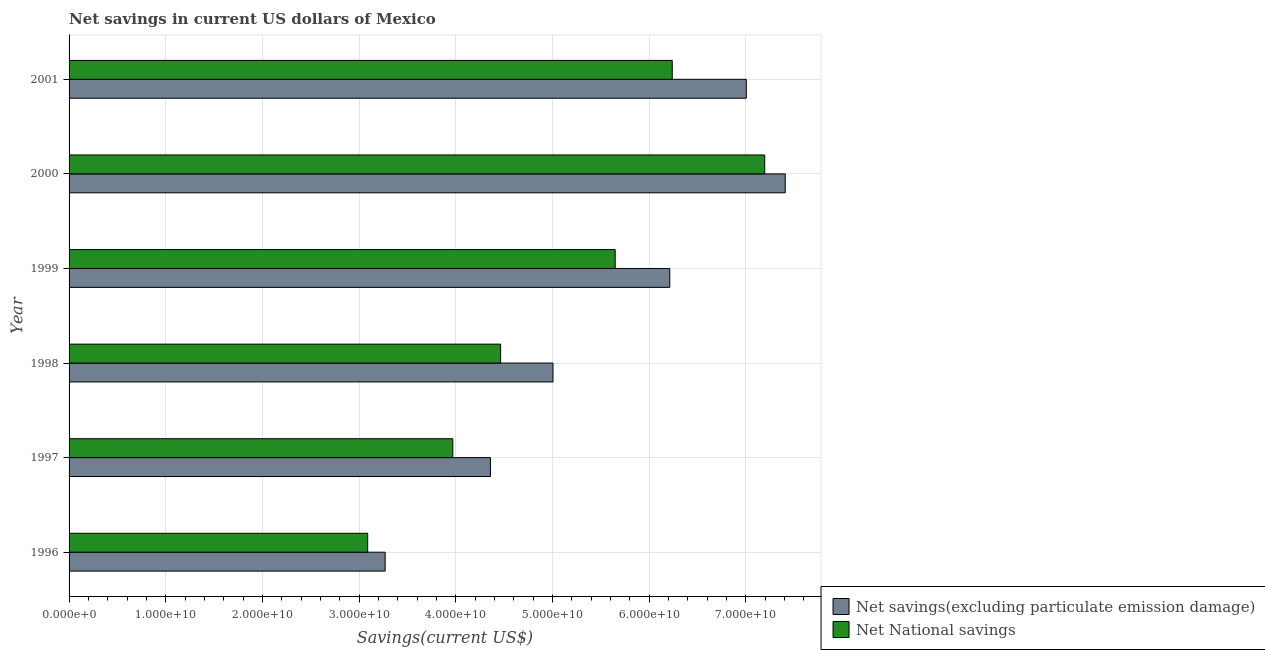How many different coloured bars are there?
Offer a terse response. 2. How many groups of bars are there?
Give a very brief answer. 6. Are the number of bars on each tick of the Y-axis equal?
Give a very brief answer. Yes. How many bars are there on the 4th tick from the top?
Ensure brevity in your answer.  2. How many bars are there on the 4th tick from the bottom?
Your response must be concise. 2. What is the label of the 4th group of bars from the top?
Offer a terse response. 1998. In how many cases, is the number of bars for a given year not equal to the number of legend labels?
Your answer should be compact. 0. What is the net national savings in 1999?
Offer a very short reply. 5.65e+1. Across all years, what is the maximum net national savings?
Ensure brevity in your answer.  7.20e+1. Across all years, what is the minimum net savings(excluding particulate emission damage)?
Offer a terse response. 3.27e+1. In which year was the net national savings maximum?
Give a very brief answer. 2000. In which year was the net national savings minimum?
Your answer should be compact. 1996. What is the total net savings(excluding particulate emission damage) in the graph?
Your answer should be very brief. 3.33e+11. What is the difference between the net national savings in 1996 and that in 2000?
Give a very brief answer. -4.11e+1. What is the difference between the net savings(excluding particulate emission damage) in 1998 and the net national savings in 1996?
Your response must be concise. 1.92e+1. What is the average net national savings per year?
Your response must be concise. 5.10e+1. In the year 1998, what is the difference between the net national savings and net savings(excluding particulate emission damage)?
Your response must be concise. -5.42e+09. What is the ratio of the net savings(excluding particulate emission damage) in 1998 to that in 2000?
Offer a very short reply. 0.68. Is the net national savings in 1998 less than that in 2001?
Your answer should be compact. Yes. Is the difference between the net national savings in 1997 and 2001 greater than the difference between the net savings(excluding particulate emission damage) in 1997 and 2001?
Keep it short and to the point. Yes. What is the difference between the highest and the second highest net national savings?
Offer a very short reply. 9.57e+09. What is the difference between the highest and the lowest net savings(excluding particulate emission damage)?
Your answer should be compact. 4.14e+1. In how many years, is the net national savings greater than the average net national savings taken over all years?
Your answer should be very brief. 3. What does the 1st bar from the top in 1998 represents?
Ensure brevity in your answer.  Net National savings. What does the 1st bar from the bottom in 1998 represents?
Keep it short and to the point. Net savings(excluding particulate emission damage). Are all the bars in the graph horizontal?
Your answer should be compact. Yes. Does the graph contain any zero values?
Make the answer very short. No. Where does the legend appear in the graph?
Your response must be concise. Bottom right. How many legend labels are there?
Ensure brevity in your answer.  2. What is the title of the graph?
Provide a succinct answer. Net savings in current US dollars of Mexico. Does "Secondary" appear as one of the legend labels in the graph?
Your response must be concise. No. What is the label or title of the X-axis?
Your response must be concise. Savings(current US$). What is the label or title of the Y-axis?
Your answer should be very brief. Year. What is the Savings(current US$) of Net savings(excluding particulate emission damage) in 1996?
Your answer should be compact. 3.27e+1. What is the Savings(current US$) of Net National savings in 1996?
Your answer should be very brief. 3.09e+1. What is the Savings(current US$) of Net savings(excluding particulate emission damage) in 1997?
Make the answer very short. 4.36e+1. What is the Savings(current US$) in Net National savings in 1997?
Offer a terse response. 3.97e+1. What is the Savings(current US$) in Net savings(excluding particulate emission damage) in 1998?
Offer a very short reply. 5.01e+1. What is the Savings(current US$) in Net National savings in 1998?
Offer a very short reply. 4.46e+1. What is the Savings(current US$) in Net savings(excluding particulate emission damage) in 1999?
Make the answer very short. 6.21e+1. What is the Savings(current US$) of Net National savings in 1999?
Provide a succinct answer. 5.65e+1. What is the Savings(current US$) in Net savings(excluding particulate emission damage) in 2000?
Keep it short and to the point. 7.41e+1. What is the Savings(current US$) of Net National savings in 2000?
Your answer should be compact. 7.20e+1. What is the Savings(current US$) in Net savings(excluding particulate emission damage) in 2001?
Offer a terse response. 7.01e+1. What is the Savings(current US$) of Net National savings in 2001?
Offer a very short reply. 6.24e+1. Across all years, what is the maximum Savings(current US$) of Net savings(excluding particulate emission damage)?
Your response must be concise. 7.41e+1. Across all years, what is the maximum Savings(current US$) of Net National savings?
Give a very brief answer. 7.20e+1. Across all years, what is the minimum Savings(current US$) of Net savings(excluding particulate emission damage)?
Give a very brief answer. 3.27e+1. Across all years, what is the minimum Savings(current US$) of Net National savings?
Your answer should be very brief. 3.09e+1. What is the total Savings(current US$) in Net savings(excluding particulate emission damage) in the graph?
Give a very brief answer. 3.33e+11. What is the total Savings(current US$) of Net National savings in the graph?
Make the answer very short. 3.06e+11. What is the difference between the Savings(current US$) in Net savings(excluding particulate emission damage) in 1996 and that in 1997?
Your answer should be very brief. -1.09e+1. What is the difference between the Savings(current US$) in Net National savings in 1996 and that in 1997?
Your response must be concise. -8.81e+09. What is the difference between the Savings(current US$) in Net savings(excluding particulate emission damage) in 1996 and that in 1998?
Your answer should be compact. -1.74e+1. What is the difference between the Savings(current US$) in Net National savings in 1996 and that in 1998?
Keep it short and to the point. -1.38e+1. What is the difference between the Savings(current US$) in Net savings(excluding particulate emission damage) in 1996 and that in 1999?
Provide a succinct answer. -2.94e+1. What is the difference between the Savings(current US$) in Net National savings in 1996 and that in 1999?
Your answer should be compact. -2.56e+1. What is the difference between the Savings(current US$) in Net savings(excluding particulate emission damage) in 1996 and that in 2000?
Offer a terse response. -4.14e+1. What is the difference between the Savings(current US$) of Net National savings in 1996 and that in 2000?
Make the answer very short. -4.11e+1. What is the difference between the Savings(current US$) of Net savings(excluding particulate emission damage) in 1996 and that in 2001?
Ensure brevity in your answer.  -3.74e+1. What is the difference between the Savings(current US$) of Net National savings in 1996 and that in 2001?
Offer a very short reply. -3.15e+1. What is the difference between the Savings(current US$) of Net savings(excluding particulate emission damage) in 1997 and that in 1998?
Provide a succinct answer. -6.47e+09. What is the difference between the Savings(current US$) of Net National savings in 1997 and that in 1998?
Make the answer very short. -4.95e+09. What is the difference between the Savings(current US$) in Net savings(excluding particulate emission damage) in 1997 and that in 1999?
Keep it short and to the point. -1.86e+1. What is the difference between the Savings(current US$) of Net National savings in 1997 and that in 1999?
Offer a terse response. -1.68e+1. What is the difference between the Savings(current US$) in Net savings(excluding particulate emission damage) in 1997 and that in 2000?
Ensure brevity in your answer.  -3.05e+1. What is the difference between the Savings(current US$) of Net National savings in 1997 and that in 2000?
Give a very brief answer. -3.23e+1. What is the difference between the Savings(current US$) in Net savings(excluding particulate emission damage) in 1997 and that in 2001?
Provide a short and direct response. -2.65e+1. What is the difference between the Savings(current US$) of Net National savings in 1997 and that in 2001?
Ensure brevity in your answer.  -2.27e+1. What is the difference between the Savings(current US$) of Net savings(excluding particulate emission damage) in 1998 and that in 1999?
Give a very brief answer. -1.21e+1. What is the difference between the Savings(current US$) in Net National savings in 1998 and that in 1999?
Your answer should be compact. -1.19e+1. What is the difference between the Savings(current US$) of Net savings(excluding particulate emission damage) in 1998 and that in 2000?
Give a very brief answer. -2.40e+1. What is the difference between the Savings(current US$) of Net National savings in 1998 and that in 2000?
Make the answer very short. -2.73e+1. What is the difference between the Savings(current US$) of Net savings(excluding particulate emission damage) in 1998 and that in 2001?
Offer a very short reply. -2.00e+1. What is the difference between the Savings(current US$) in Net National savings in 1998 and that in 2001?
Give a very brief answer. -1.78e+1. What is the difference between the Savings(current US$) of Net savings(excluding particulate emission damage) in 1999 and that in 2000?
Your answer should be very brief. -1.19e+1. What is the difference between the Savings(current US$) in Net National savings in 1999 and that in 2000?
Provide a short and direct response. -1.55e+1. What is the difference between the Savings(current US$) of Net savings(excluding particulate emission damage) in 1999 and that in 2001?
Provide a short and direct response. -7.92e+09. What is the difference between the Savings(current US$) of Net National savings in 1999 and that in 2001?
Offer a terse response. -5.90e+09. What is the difference between the Savings(current US$) of Net savings(excluding particulate emission damage) in 2000 and that in 2001?
Give a very brief answer. 4.03e+09. What is the difference between the Savings(current US$) in Net National savings in 2000 and that in 2001?
Give a very brief answer. 9.57e+09. What is the difference between the Savings(current US$) of Net savings(excluding particulate emission damage) in 1996 and the Savings(current US$) of Net National savings in 1997?
Keep it short and to the point. -7.00e+09. What is the difference between the Savings(current US$) in Net savings(excluding particulate emission damage) in 1996 and the Savings(current US$) in Net National savings in 1998?
Give a very brief answer. -1.19e+1. What is the difference between the Savings(current US$) of Net savings(excluding particulate emission damage) in 1996 and the Savings(current US$) of Net National savings in 1999?
Give a very brief answer. -2.38e+1. What is the difference between the Savings(current US$) of Net savings(excluding particulate emission damage) in 1996 and the Savings(current US$) of Net National savings in 2000?
Offer a terse response. -3.93e+1. What is the difference between the Savings(current US$) of Net savings(excluding particulate emission damage) in 1996 and the Savings(current US$) of Net National savings in 2001?
Make the answer very short. -2.97e+1. What is the difference between the Savings(current US$) in Net savings(excluding particulate emission damage) in 1997 and the Savings(current US$) in Net National savings in 1998?
Keep it short and to the point. -1.05e+09. What is the difference between the Savings(current US$) of Net savings(excluding particulate emission damage) in 1997 and the Savings(current US$) of Net National savings in 1999?
Keep it short and to the point. -1.29e+1. What is the difference between the Savings(current US$) in Net savings(excluding particulate emission damage) in 1997 and the Savings(current US$) in Net National savings in 2000?
Offer a terse response. -2.84e+1. What is the difference between the Savings(current US$) in Net savings(excluding particulate emission damage) in 1997 and the Savings(current US$) in Net National savings in 2001?
Your answer should be very brief. -1.88e+1. What is the difference between the Savings(current US$) of Net savings(excluding particulate emission damage) in 1998 and the Savings(current US$) of Net National savings in 1999?
Your answer should be compact. -6.43e+09. What is the difference between the Savings(current US$) in Net savings(excluding particulate emission damage) in 1998 and the Savings(current US$) in Net National savings in 2000?
Ensure brevity in your answer.  -2.19e+1. What is the difference between the Savings(current US$) of Net savings(excluding particulate emission damage) in 1998 and the Savings(current US$) of Net National savings in 2001?
Your answer should be compact. -1.23e+1. What is the difference between the Savings(current US$) in Net savings(excluding particulate emission damage) in 1999 and the Savings(current US$) in Net National savings in 2000?
Your answer should be compact. -9.82e+09. What is the difference between the Savings(current US$) of Net savings(excluding particulate emission damage) in 1999 and the Savings(current US$) of Net National savings in 2001?
Give a very brief answer. -2.57e+08. What is the difference between the Savings(current US$) of Net savings(excluding particulate emission damage) in 2000 and the Savings(current US$) of Net National savings in 2001?
Make the answer very short. 1.17e+1. What is the average Savings(current US$) in Net savings(excluding particulate emission damage) per year?
Your answer should be very brief. 5.54e+1. What is the average Savings(current US$) in Net National savings per year?
Ensure brevity in your answer.  5.10e+1. In the year 1996, what is the difference between the Savings(current US$) of Net savings(excluding particulate emission damage) and Savings(current US$) of Net National savings?
Provide a short and direct response. 1.81e+09. In the year 1997, what is the difference between the Savings(current US$) of Net savings(excluding particulate emission damage) and Savings(current US$) of Net National savings?
Provide a succinct answer. 3.89e+09. In the year 1998, what is the difference between the Savings(current US$) in Net savings(excluding particulate emission damage) and Savings(current US$) in Net National savings?
Provide a short and direct response. 5.42e+09. In the year 1999, what is the difference between the Savings(current US$) of Net savings(excluding particulate emission damage) and Savings(current US$) of Net National savings?
Ensure brevity in your answer.  5.65e+09. In the year 2000, what is the difference between the Savings(current US$) of Net savings(excluding particulate emission damage) and Savings(current US$) of Net National savings?
Provide a short and direct response. 2.12e+09. In the year 2001, what is the difference between the Savings(current US$) in Net savings(excluding particulate emission damage) and Savings(current US$) in Net National savings?
Give a very brief answer. 7.66e+09. What is the ratio of the Savings(current US$) in Net savings(excluding particulate emission damage) in 1996 to that in 1997?
Your answer should be very brief. 0.75. What is the ratio of the Savings(current US$) in Net National savings in 1996 to that in 1997?
Ensure brevity in your answer.  0.78. What is the ratio of the Savings(current US$) of Net savings(excluding particulate emission damage) in 1996 to that in 1998?
Give a very brief answer. 0.65. What is the ratio of the Savings(current US$) of Net National savings in 1996 to that in 1998?
Your answer should be very brief. 0.69. What is the ratio of the Savings(current US$) in Net savings(excluding particulate emission damage) in 1996 to that in 1999?
Offer a terse response. 0.53. What is the ratio of the Savings(current US$) of Net National savings in 1996 to that in 1999?
Ensure brevity in your answer.  0.55. What is the ratio of the Savings(current US$) of Net savings(excluding particulate emission damage) in 1996 to that in 2000?
Your answer should be very brief. 0.44. What is the ratio of the Savings(current US$) in Net National savings in 1996 to that in 2000?
Your response must be concise. 0.43. What is the ratio of the Savings(current US$) in Net savings(excluding particulate emission damage) in 1996 to that in 2001?
Make the answer very short. 0.47. What is the ratio of the Savings(current US$) of Net National savings in 1996 to that in 2001?
Make the answer very short. 0.5. What is the ratio of the Savings(current US$) in Net savings(excluding particulate emission damage) in 1997 to that in 1998?
Keep it short and to the point. 0.87. What is the ratio of the Savings(current US$) of Net National savings in 1997 to that in 1998?
Your response must be concise. 0.89. What is the ratio of the Savings(current US$) of Net savings(excluding particulate emission damage) in 1997 to that in 1999?
Offer a very short reply. 0.7. What is the ratio of the Savings(current US$) in Net National savings in 1997 to that in 1999?
Keep it short and to the point. 0.7. What is the ratio of the Savings(current US$) of Net savings(excluding particulate emission damage) in 1997 to that in 2000?
Provide a short and direct response. 0.59. What is the ratio of the Savings(current US$) in Net National savings in 1997 to that in 2000?
Your response must be concise. 0.55. What is the ratio of the Savings(current US$) in Net savings(excluding particulate emission damage) in 1997 to that in 2001?
Your response must be concise. 0.62. What is the ratio of the Savings(current US$) of Net National savings in 1997 to that in 2001?
Your answer should be compact. 0.64. What is the ratio of the Savings(current US$) of Net savings(excluding particulate emission damage) in 1998 to that in 1999?
Provide a succinct answer. 0.81. What is the ratio of the Savings(current US$) of Net National savings in 1998 to that in 1999?
Provide a succinct answer. 0.79. What is the ratio of the Savings(current US$) in Net savings(excluding particulate emission damage) in 1998 to that in 2000?
Make the answer very short. 0.68. What is the ratio of the Savings(current US$) of Net National savings in 1998 to that in 2000?
Your answer should be compact. 0.62. What is the ratio of the Savings(current US$) in Net savings(excluding particulate emission damage) in 1998 to that in 2001?
Ensure brevity in your answer.  0.71. What is the ratio of the Savings(current US$) in Net National savings in 1998 to that in 2001?
Give a very brief answer. 0.72. What is the ratio of the Savings(current US$) in Net savings(excluding particulate emission damage) in 1999 to that in 2000?
Offer a very short reply. 0.84. What is the ratio of the Savings(current US$) of Net National savings in 1999 to that in 2000?
Your answer should be compact. 0.79. What is the ratio of the Savings(current US$) of Net savings(excluding particulate emission damage) in 1999 to that in 2001?
Your answer should be compact. 0.89. What is the ratio of the Savings(current US$) in Net National savings in 1999 to that in 2001?
Offer a very short reply. 0.91. What is the ratio of the Savings(current US$) in Net savings(excluding particulate emission damage) in 2000 to that in 2001?
Keep it short and to the point. 1.06. What is the ratio of the Savings(current US$) in Net National savings in 2000 to that in 2001?
Give a very brief answer. 1.15. What is the difference between the highest and the second highest Savings(current US$) of Net savings(excluding particulate emission damage)?
Offer a terse response. 4.03e+09. What is the difference between the highest and the second highest Savings(current US$) in Net National savings?
Your answer should be very brief. 9.57e+09. What is the difference between the highest and the lowest Savings(current US$) in Net savings(excluding particulate emission damage)?
Your answer should be compact. 4.14e+1. What is the difference between the highest and the lowest Savings(current US$) in Net National savings?
Your response must be concise. 4.11e+1. 